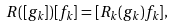Convert formula to latex. <formula><loc_0><loc_0><loc_500><loc_500>R ( [ g _ { k } ] ) [ f _ { k } ] = [ R _ { k } ( g _ { k } ) f _ { k } ] ,</formula> 